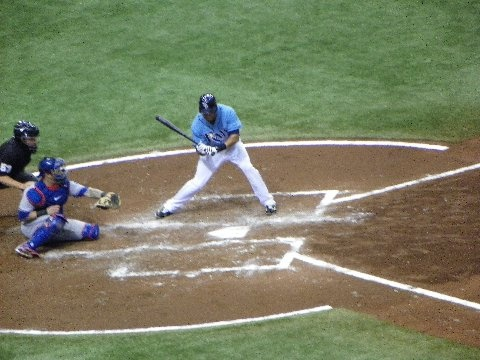Describe the objects in this image and their specific colors. I can see people in darkgreen, lavender, darkgray, and lightblue tones, people in darkgreen, navy, gray, black, and darkgray tones, people in darkgreen, black, gray, and darkgray tones, baseball glove in darkgreen, gray, darkgray, and beige tones, and baseball bat in darkgreen, gray, black, and darkgray tones in this image. 